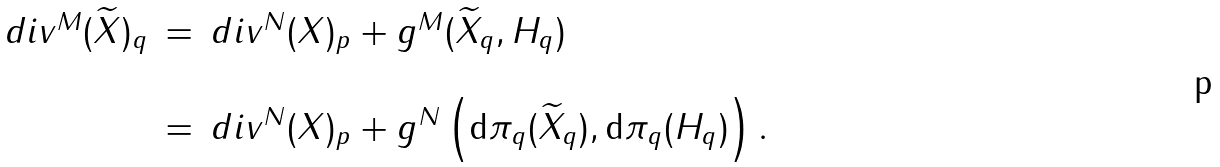<formula> <loc_0><loc_0><loc_500><loc_500>\begin{array} { l l l } d i v ^ { M } ( \widetilde { X } ) _ { q } & = & d i v ^ { N } ( X ) _ { p } + g ^ { M } ( \widetilde { X } _ { q } , H _ { q } ) \\ & & \\ & = & d i v ^ { N } ( X ) _ { p } + g ^ { N } \left ( \mathrm d \pi _ { q } ( \widetilde { X } _ { q } ) , \mathrm d \pi _ { q } ( H _ { q } ) \right ) . \end{array}</formula> 